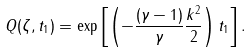<formula> <loc_0><loc_0><loc_500><loc_500>Q ( \zeta , t _ { 1 } ) = \exp \left [ \left ( - \frac { ( \gamma - 1 ) } { \gamma } \frac { k ^ { 2 } } { 2 } \right ) t _ { 1 } \right ] .</formula> 